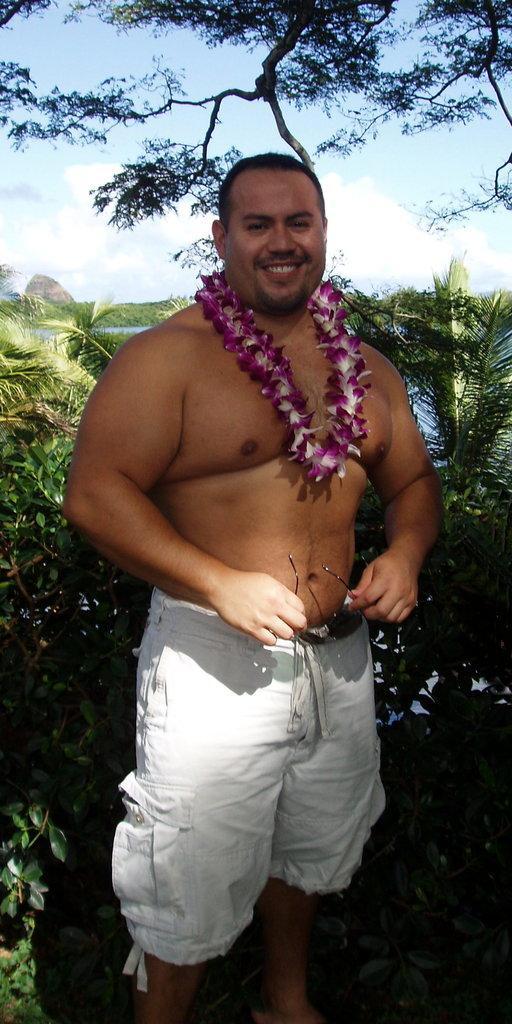Can you describe this image briefly? In this image I can see a man standing, wearing a garland and white shorts. He is holding goggles in his hands. There are trees and water behind him. There is sky at the top. 